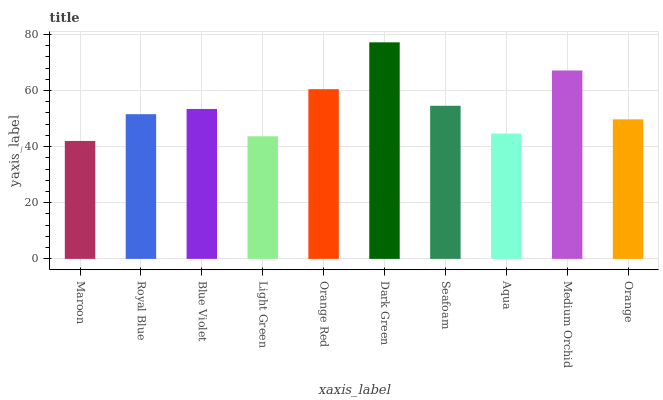Is Maroon the minimum?
Answer yes or no. Yes. Is Dark Green the maximum?
Answer yes or no. Yes. Is Royal Blue the minimum?
Answer yes or no. No. Is Royal Blue the maximum?
Answer yes or no. No. Is Royal Blue greater than Maroon?
Answer yes or no. Yes. Is Maroon less than Royal Blue?
Answer yes or no. Yes. Is Maroon greater than Royal Blue?
Answer yes or no. No. Is Royal Blue less than Maroon?
Answer yes or no. No. Is Blue Violet the high median?
Answer yes or no. Yes. Is Royal Blue the low median?
Answer yes or no. Yes. Is Dark Green the high median?
Answer yes or no. No. Is Medium Orchid the low median?
Answer yes or no. No. 